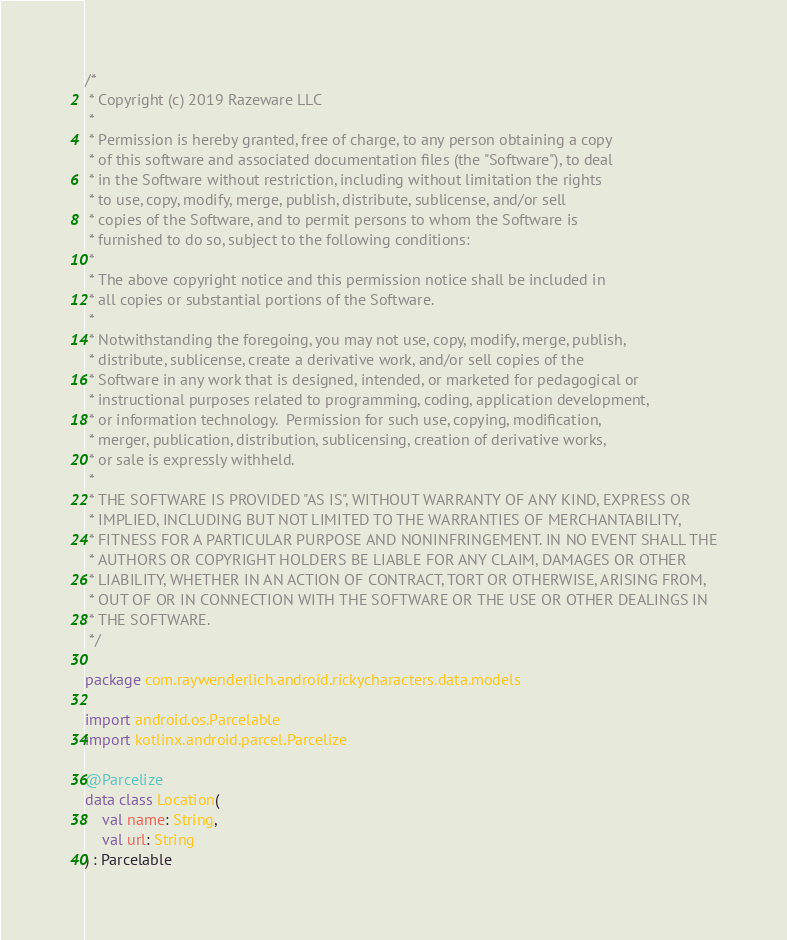Convert code to text. <code><loc_0><loc_0><loc_500><loc_500><_Kotlin_>/*
 * Copyright (c) 2019 Razeware LLC
 *
 * Permission is hereby granted, free of charge, to any person obtaining a copy
 * of this software and associated documentation files (the "Software"), to deal
 * in the Software without restriction, including without limitation the rights
 * to use, copy, modify, merge, publish, distribute, sublicense, and/or sell
 * copies of the Software, and to permit persons to whom the Software is
 * furnished to do so, subject to the following conditions:
 *
 * The above copyright notice and this permission notice shall be included in
 * all copies or substantial portions of the Software.
 *
 * Notwithstanding the foregoing, you may not use, copy, modify, merge, publish,
 * distribute, sublicense, create a derivative work, and/or sell copies of the
 * Software in any work that is designed, intended, or marketed for pedagogical or
 * instructional purposes related to programming, coding, application development,
 * or information technology.  Permission for such use, copying, modification,
 * merger, publication, distribution, sublicensing, creation of derivative works,
 * or sale is expressly withheld.
 *
 * THE SOFTWARE IS PROVIDED "AS IS", WITHOUT WARRANTY OF ANY KIND, EXPRESS OR
 * IMPLIED, INCLUDING BUT NOT LIMITED TO THE WARRANTIES OF MERCHANTABILITY,
 * FITNESS FOR A PARTICULAR PURPOSE AND NONINFRINGEMENT. IN NO EVENT SHALL THE
 * AUTHORS OR COPYRIGHT HOLDERS BE LIABLE FOR ANY CLAIM, DAMAGES OR OTHER
 * LIABILITY, WHETHER IN AN ACTION OF CONTRACT, TORT OR OTHERWISE, ARISING FROM,
 * OUT OF OR IN CONNECTION WITH THE SOFTWARE OR THE USE OR OTHER DEALINGS IN
 * THE SOFTWARE.
 */

package com.raywenderlich.android.rickycharacters.data.models

import android.os.Parcelable
import kotlinx.android.parcel.Parcelize

@Parcelize
data class Location(
    val name: String,
    val url: String
) : Parcelable</code> 